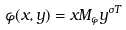Convert formula to latex. <formula><loc_0><loc_0><loc_500><loc_500>\varphi ( x , y ) = x M _ { \varphi } y ^ { \sigma T }</formula> 